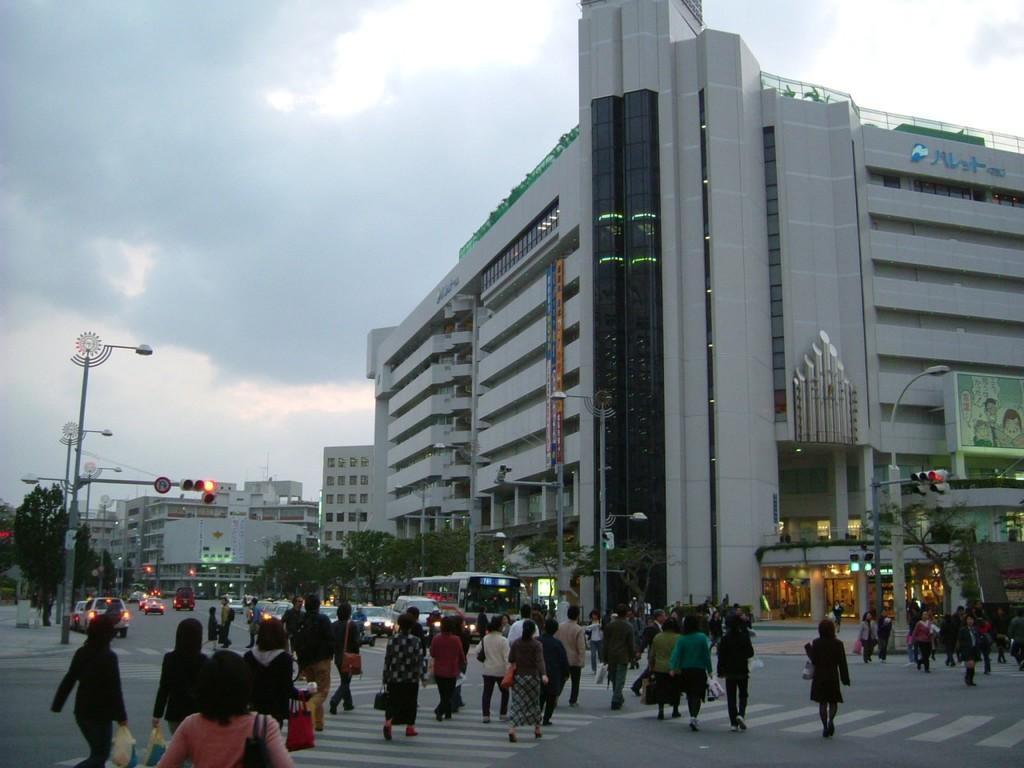In one or two sentences, can you explain what this image depicts? In this picture we can see some people walking on the road and on the road there are some vehicles. On the left side of the people there are poles with lights, a sign board and traffic signals. On the right side of the people there are trees and buildings. It looks like a hoarding and a name board attached to the building. Behind the buildings there is the sky. 